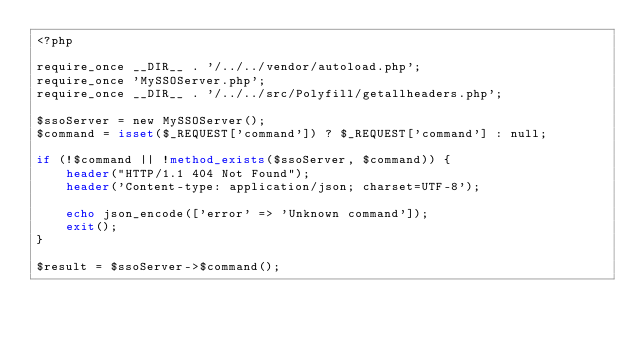Convert code to text. <code><loc_0><loc_0><loc_500><loc_500><_PHP_><?php

require_once __DIR__ . '/../../vendor/autoload.php';
require_once 'MySSOServer.php';
require_once __DIR__ . '/../../src/Polyfill/getallheaders.php';

$ssoServer = new MySSOServer();
$command = isset($_REQUEST['command']) ? $_REQUEST['command'] : null;

if (!$command || !method_exists($ssoServer, $command)) {
    header("HTTP/1.1 404 Not Found");
    header('Content-type: application/json; charset=UTF-8');
    
    echo json_encode(['error' => 'Unknown command']);
    exit();
}

$result = $ssoServer->$command();

</code> 